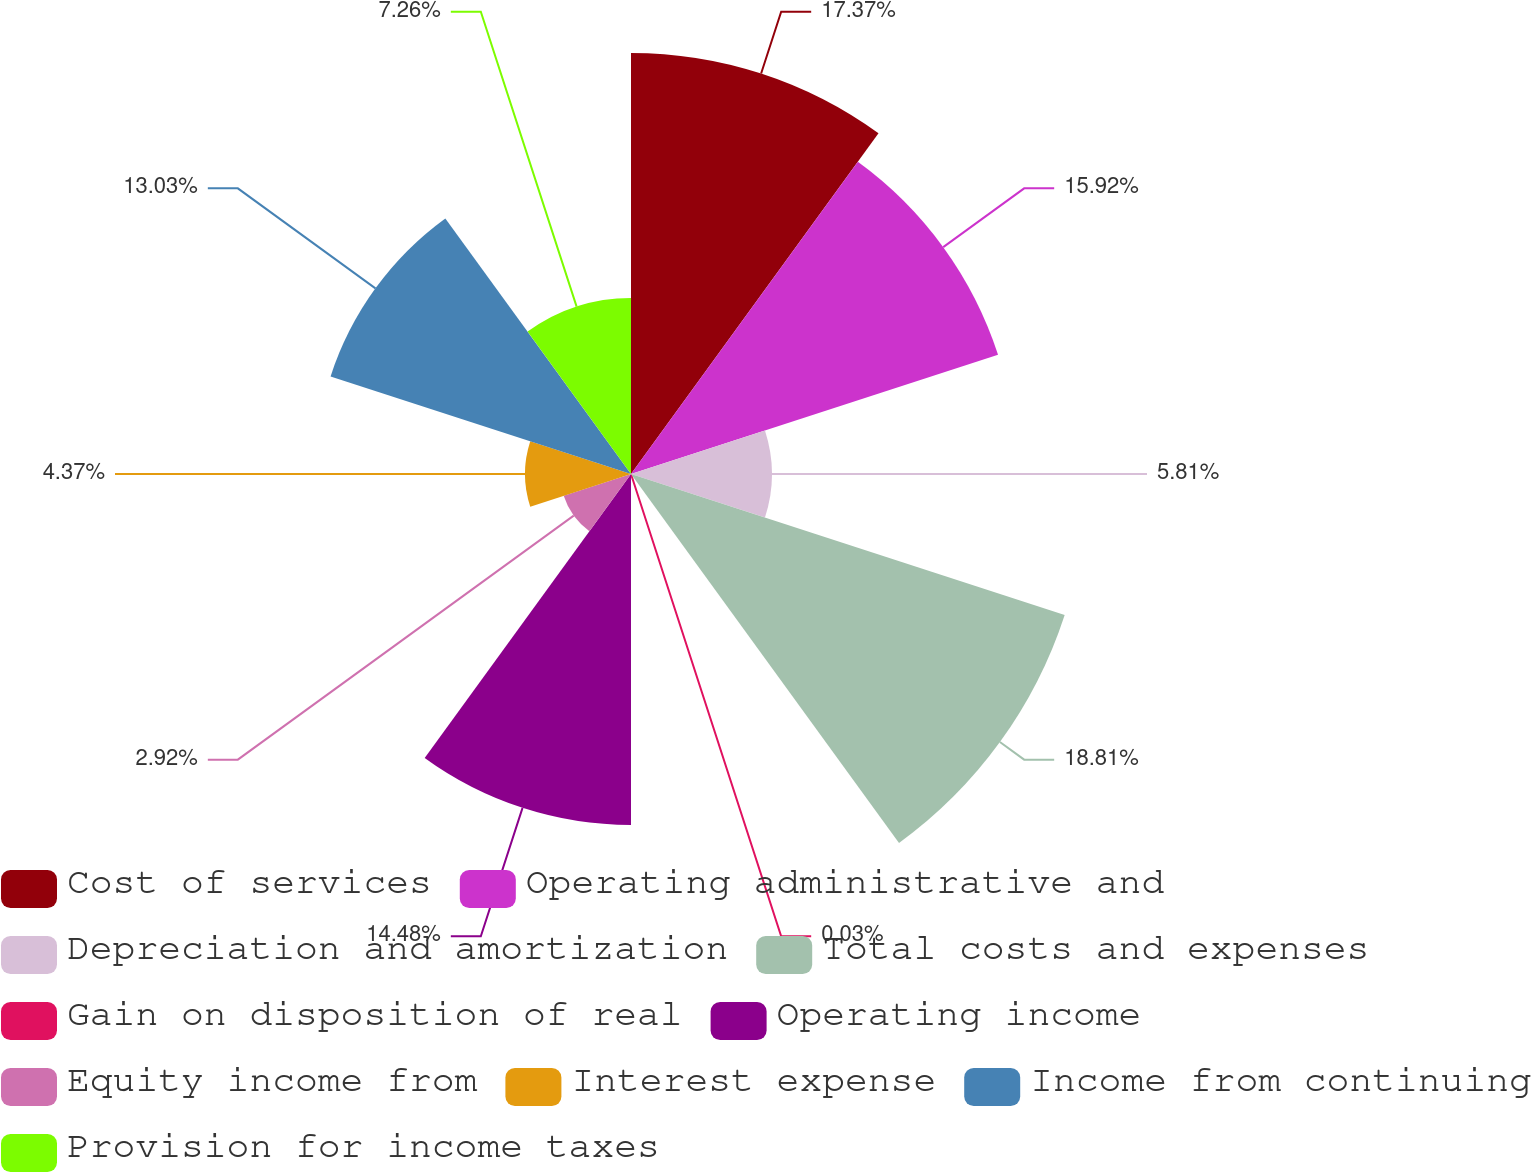Convert chart. <chart><loc_0><loc_0><loc_500><loc_500><pie_chart><fcel>Cost of services<fcel>Operating administrative and<fcel>Depreciation and amortization<fcel>Total costs and expenses<fcel>Gain on disposition of real<fcel>Operating income<fcel>Equity income from<fcel>Interest expense<fcel>Income from continuing<fcel>Provision for income taxes<nl><fcel>17.37%<fcel>15.92%<fcel>5.81%<fcel>18.81%<fcel>0.03%<fcel>14.48%<fcel>2.92%<fcel>4.37%<fcel>13.03%<fcel>7.26%<nl></chart> 